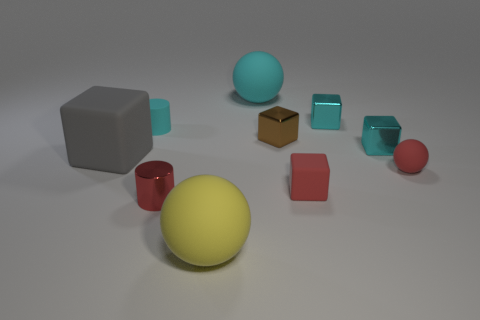What number of matte objects are large gray objects or red blocks?
Ensure brevity in your answer.  2. The small rubber thing that is the same color as the small rubber block is what shape?
Your answer should be very brief. Sphere. There is a red ball that is in front of the brown metallic thing; what material is it?
Make the answer very short. Rubber. What number of objects are either big cyan matte spheres or tiny red objects that are in front of the small red rubber block?
Keep it short and to the point. 2. There is a cyan rubber object that is the same size as the brown object; what is its shape?
Your answer should be very brief. Cylinder. How many tiny things have the same color as the big cube?
Ensure brevity in your answer.  0. Is the ball behind the cyan cylinder made of the same material as the small red ball?
Your answer should be very brief. Yes. The big yellow rubber thing has what shape?
Give a very brief answer. Sphere. How many gray things are shiny things or tiny metallic balls?
Offer a very short reply. 0. What number of other objects are the same material as the tiny ball?
Offer a very short reply. 5. 